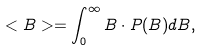Convert formula to latex. <formula><loc_0><loc_0><loc_500><loc_500>< B > = \int _ { 0 } ^ { \infty } B \cdot P ( B ) d B ,</formula> 